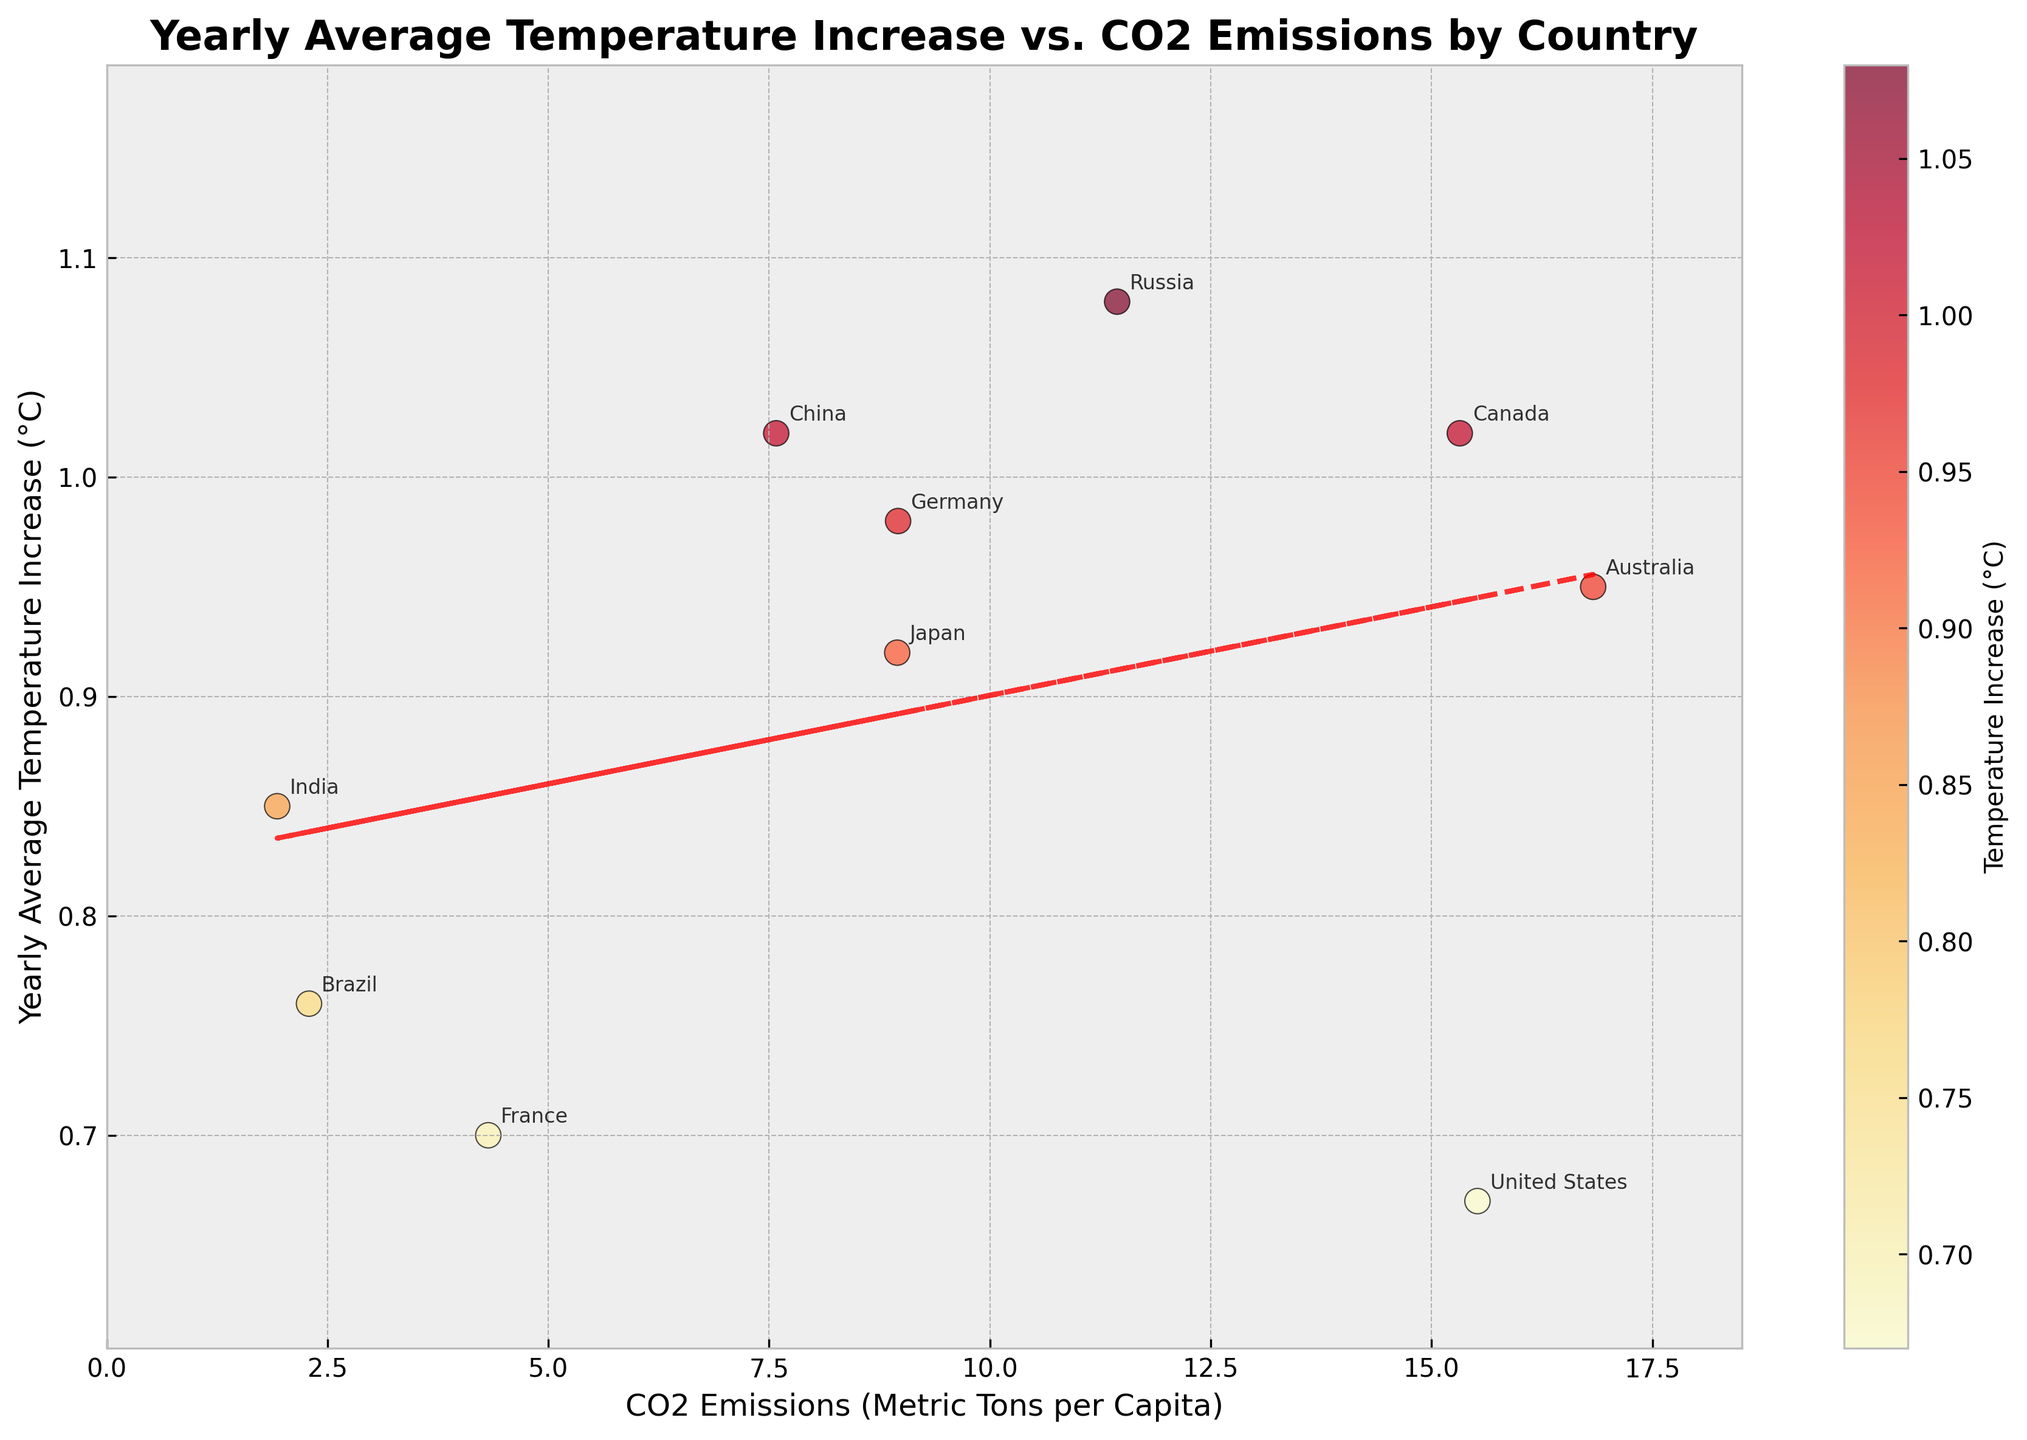What is the title of the plot? The title of the plot is displayed at the top of the figure.
Answer: Yearly Average Temperature Increase vs. CO2 Emissions by Country What do the x-axis and y-axis represent? The x-axis represents 'CO2 Emissions (Metric Tons per Capita)' and the y-axis represents 'Yearly Average Temperature Increase (°C)'. This information is found from the axis labels.
Answer: CO2 Emissions and Yearly Average Temperature Increase Which country has the highest CO2 emissions? From the scatter plot, the data point farthest to the right on the x-axis represents the highest CO2 emissions. Here, Australia has the highest CO2 emissions.
Answer: Australia Which country has the highest yearly average temperature increase? The country with the highest yearly average temperature increase is represented by the data point that is the highest on the y-axis. From the plot, Russia has the highest yearly average temperature increase.
Answer: Russia Are there any countries with both low CO2 emissions and low-temperature increases? By looking at the lower left corner of the plot, we can identify countries with both low CO2 emissions and low-temperature increases. France fits this criteria.
Answer: France What's the trend indicated by the trend line? The trend line shows the general relationship between the two variables. A red dashed trend line with a positive slope suggests that as CO2 emissions increase, the yearly average temperature increase also tends to rise.
Answer: Positive correlation Which two countries have the closest CO2 emissions but different temperature increases? By finding points close to each other on the x-axis but disparate on the y-axis, Canada and the United States have similar CO2 emissions but different temperature increases.
Answer: Canada and United States Is there any country with a temperature increase above 1°C and CO2 emissions below 10 metric tons per capita? Points that are above the 1°C line on the y-axis and to the left of the 10 metric tons per capita line on the x-axis show countries meeting the criteria. India and China fit this condition.
Answer: India and China How many countries have a yearly average temperature increase above 0.9°C? We count the number of points above the 0.9°C mark on the y-axis. There are five such countries: China, Germany, Russia, Australia, and Canada.
Answer: Five 